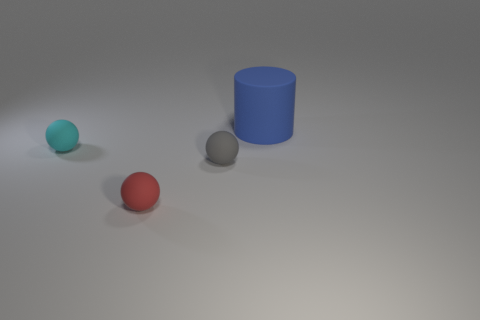Could these objects be used to explain basic geometry? Yes, these objects are perfect for a basic geometry lesson. The teal and red spheres can be used to explain properties of spheres, such as symmetry and absence of edges, while the blue cylinder can be used to discuss cylindrical shapes including faces, edges, and how it rolls differently compared to spheres. 